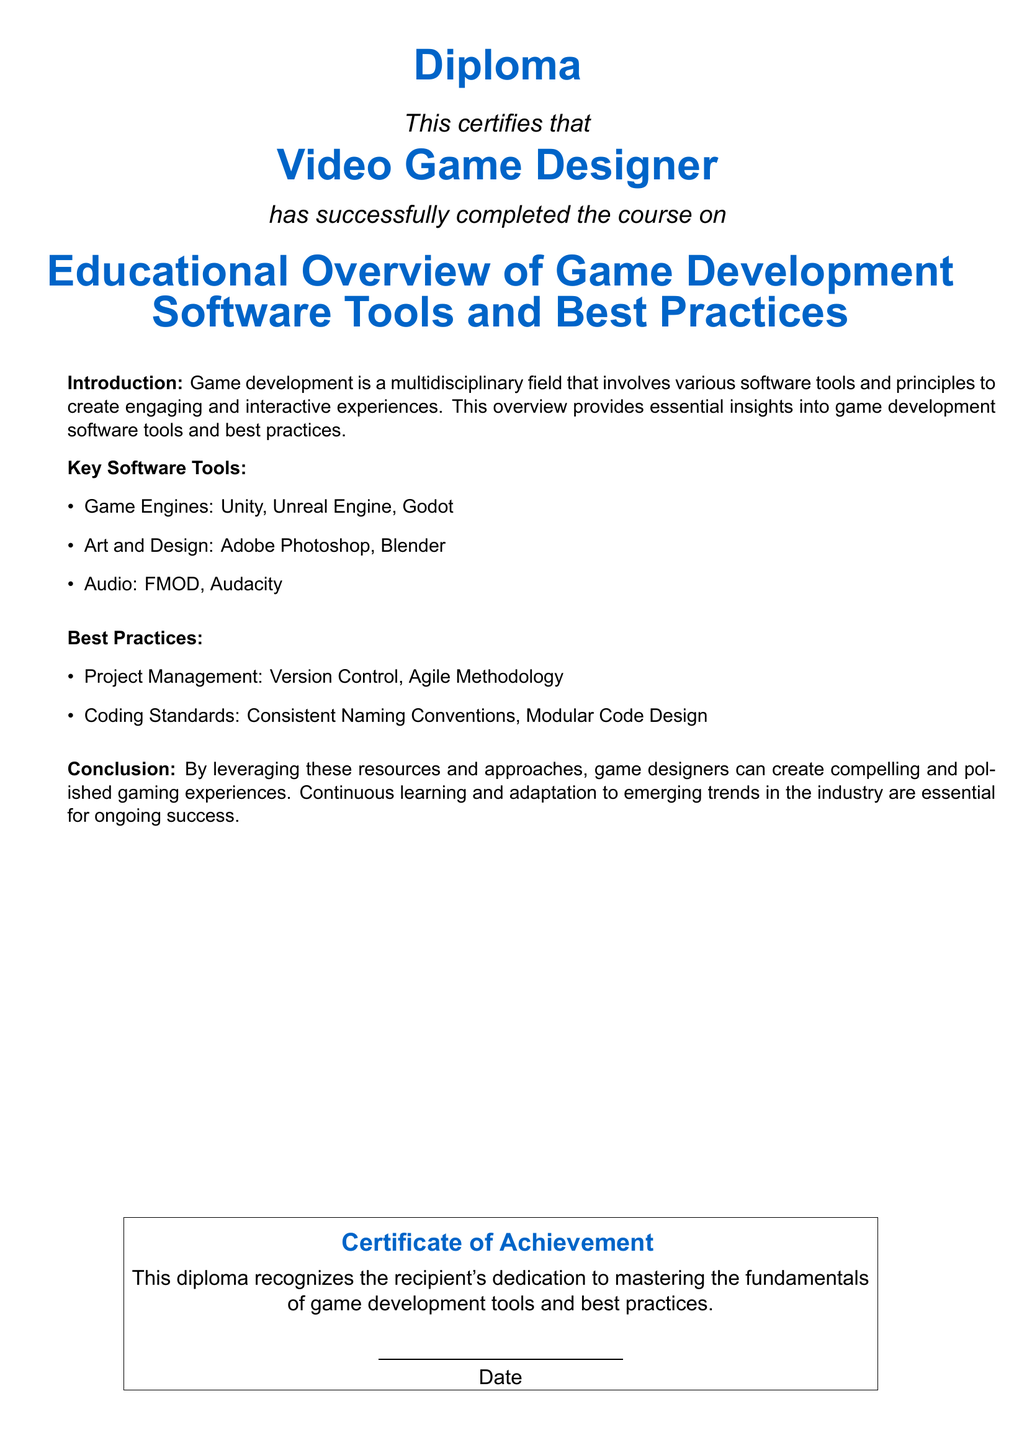What is the title of the diploma? The title of the diploma is prominently displayed in the document as the main focus for recognition.
Answer: Educational Overview of Game Development Software Tools and Best Practices Who completed the course? The course completion is certified for a specific title mentioned in the document.
Answer: Video Game Designer What are the three key game engines listed? The document lists important software tools in game development, including three specific game engines.
Answer: Unity, Unreal Engine, Godot What is one audio tool mentioned? The document includes various software tools for audio in game development.
Answer: FMOD What is one best practice in project management? The document highlights important best practices to follow in game development, including aspects of project management.
Answer: Agile Methodology What color is used for the section titles? The document uses specific colors for different elements; the section titles have a distinctive color.
Answer: Gameblue What does the diploma recognize? The last part of the document specifies what the diploma achieves or acknowledges about the recipient.
Answer: Dedication to mastering the fundamentals of game development tools and best practices What does the document state are essential for success? The conclusion summarizes what is vital for ongoing success in the field presented in the document.
Answer: Continuous learning and adaptation to emerging trends in the industry 